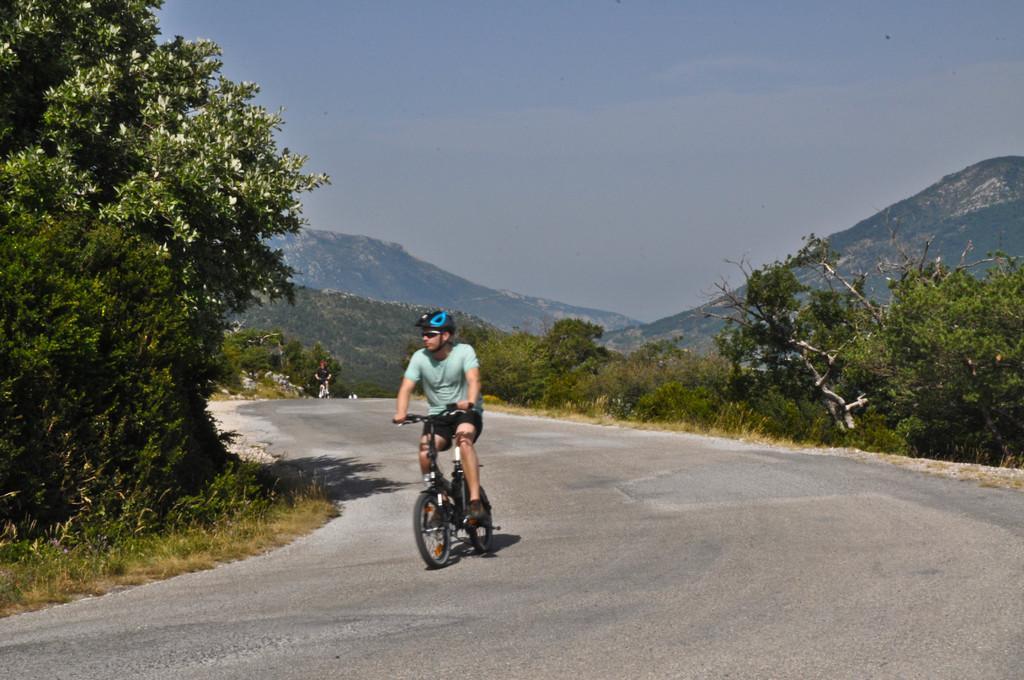How would you summarize this image in a sentence or two? In the middle of the image we can see a person is riding bicycle and he is wearing a helmet, in the background we can find few trees, hills and another person. 